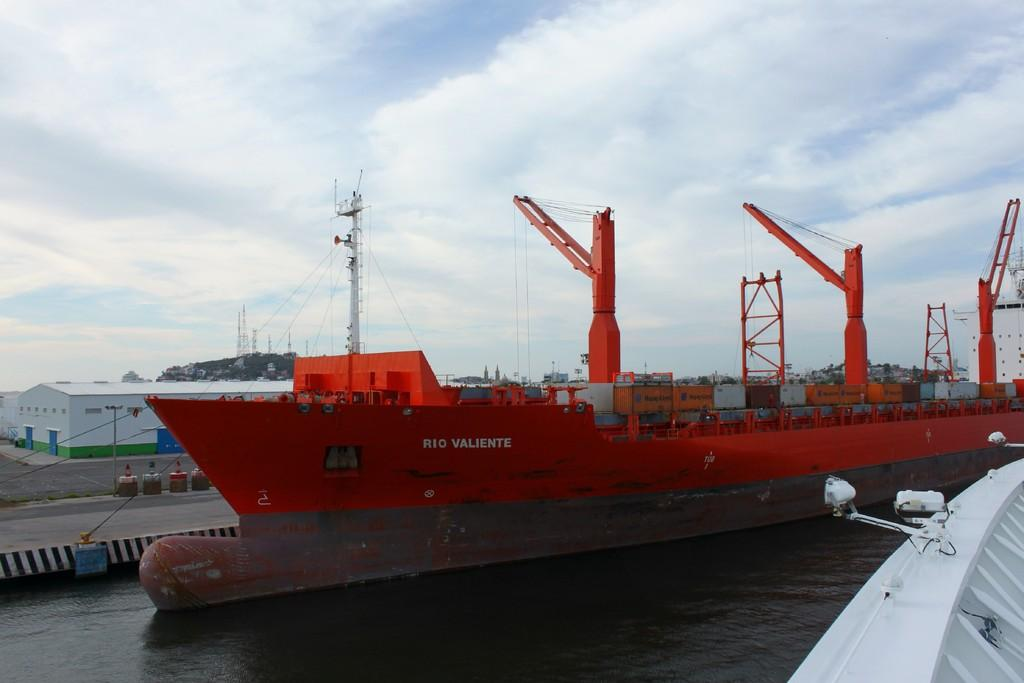<image>
Describe the image concisely. A large red cargo ship called the Rio Valiente is parked in a bay. 